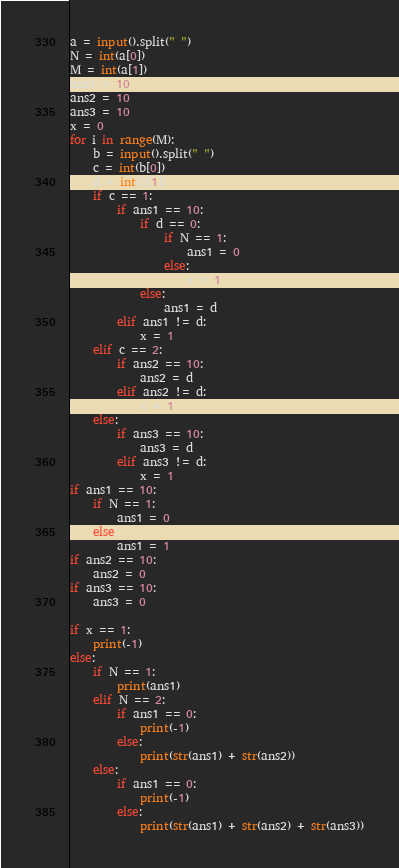<code> <loc_0><loc_0><loc_500><loc_500><_Python_>a = input().split(" ")
N = int(a[0])
M = int(a[1])
ans1 = 10
ans2 = 10
ans3 = 10
x = 0
for i in range(M):
    b = input().split(" ")
    c = int(b[0])
    d = int(b[1])
    if c == 1:
        if ans1 == 10:
            if d == 0:
                if N == 1:
                    ans1 = 0
                else:
                    x = 1
            else:
                ans1 = d
        elif ans1 != d:
            x = 1
    elif c == 2:
        if ans2 == 10:
            ans2 = d
        elif ans2 != d:
            x = 1
    else:
        if ans3 == 10:
            ans3 = d
        elif ans3 != d:
            x = 1
if ans1 == 10:
    if N == 1:
        ans1 = 0
    else:
        ans1 = 1
if ans2 == 10:
    ans2 = 0
if ans3 == 10:
    ans3 = 0

if x == 1:
    print(-1)
else:
    if N == 1:
        print(ans1)
    elif N == 2:
        if ans1 == 0:
            print(-1)
        else:
            print(str(ans1) + str(ans2))
    else:
        if ans1 == 0:
            print(-1)
        else:
            print(str(ans1) + str(ans2) + str(ans3))</code> 